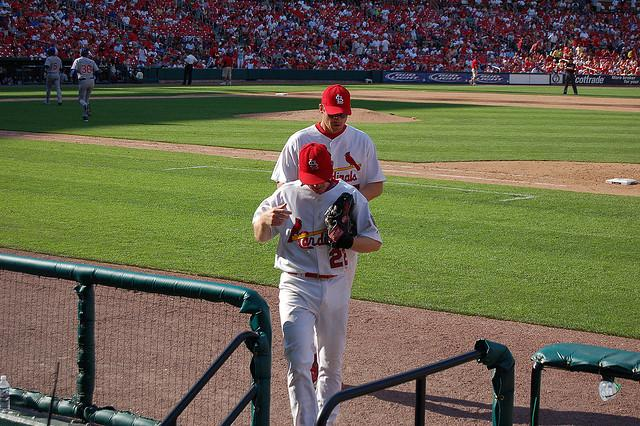At which location are the Cardinals playing? arizona 